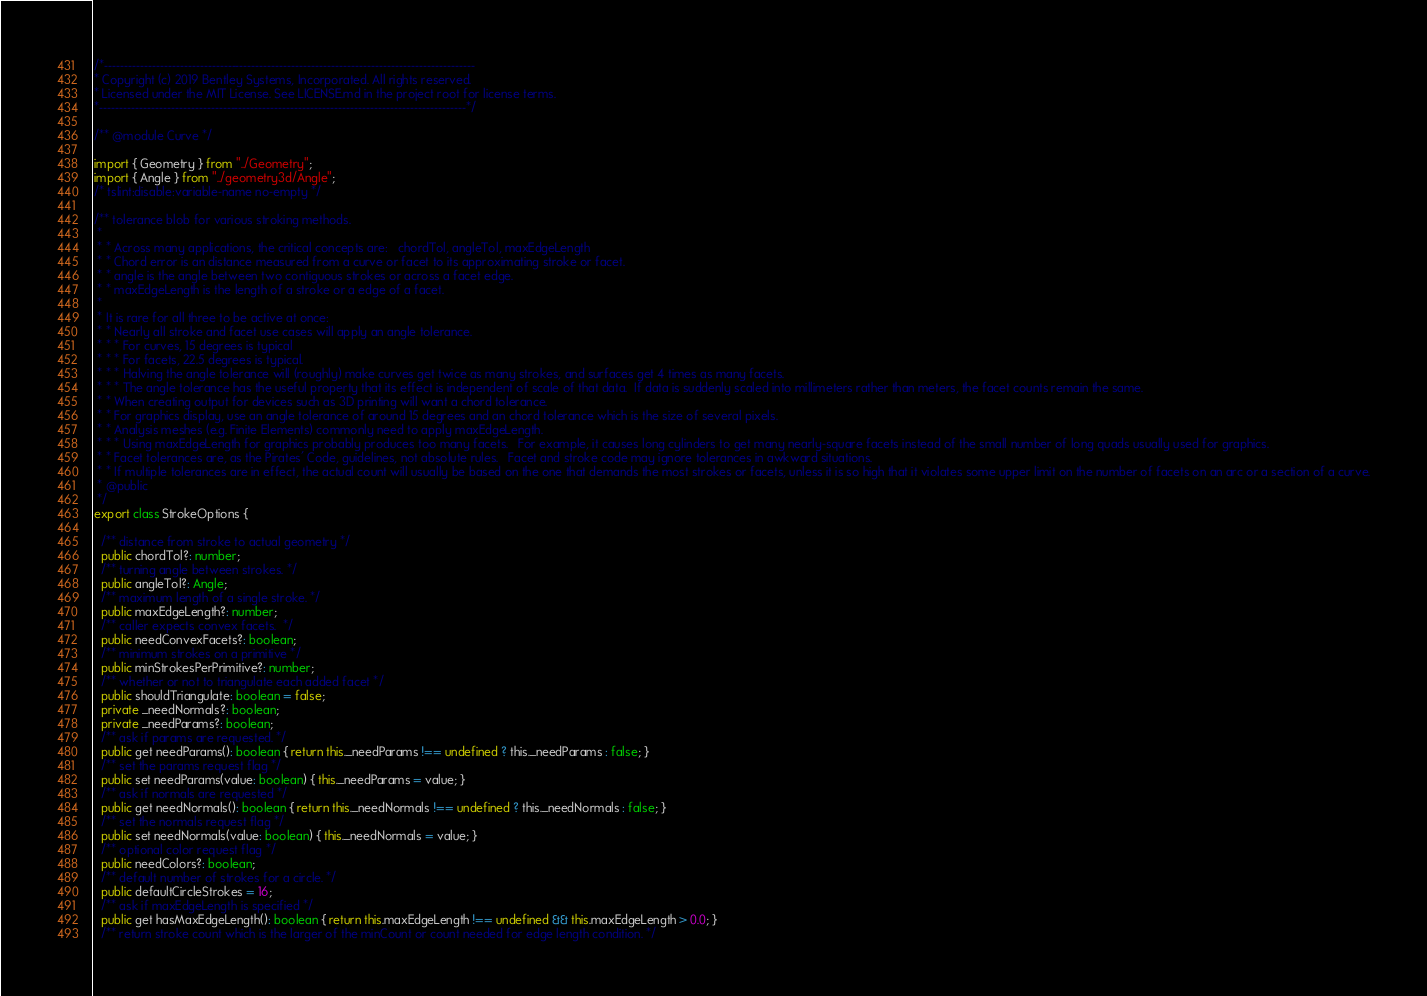<code> <loc_0><loc_0><loc_500><loc_500><_TypeScript_>/*---------------------------------------------------------------------------------------------
* Copyright (c) 2019 Bentley Systems, Incorporated. All rights reserved.
* Licensed under the MIT License. See LICENSE.md in the project root for license terms.
*--------------------------------------------------------------------------------------------*/

/** @module Curve */

import { Geometry } from "../Geometry";
import { Angle } from "../geometry3d/Angle";
/* tslint:disable:variable-name no-empty */

/** tolerance blob for various stroking methods.
 *
 * * Across many applications, the critical concepts are:   chordTol, angleTol, maxEdgeLength
 * * Chord error is an distance measured from a curve or facet to its approximating stroke or facet.
 * * angle is the angle between two contiguous strokes or across a facet edge.
 * * maxEdgeLength is the length of a stroke or a edge of a facet.
 *
 * It is rare for all three to be active at once:
 * * Nearly all stroke and facet use cases will apply an angle tolerance.
 * * * For curves, 15 degrees is typical
 * * * For facets, 22.5 degrees is typical.
 * * * Halving the angle tolerance will (roughly) make curves get twice as many strokes, and surfaces get 4 times as many facets.
 * * * The angle tolerance has the useful property that its effect is independent of scale of that data.  If data is suddenly scaled into millimeters rather than meters, the facet counts remain the same.
 * * When creating output for devices such as 3D printing will want a chord tolerance.
 * * For graphics display, use an angle tolerance of around 15 degrees and an chord tolerance which is the size of several pixels.
 * * Analysis meshes (e.g. Finite Elements) commonly need to apply maxEdgeLength.
 * * * Using maxEdgeLength for graphics probably produces too many facets.   For example, it causes long cylinders to get many nearly-square facets instead of the small number of long quads usually used for graphics.
 * * Facet tolerances are, as the Pirates' Code, guidelines, not absolute rules.   Facet and stroke code may ignore tolerances in awkward situations.
 * * If multiple tolerances are in effect, the actual count will usually be based on the one that demands the most strokes or facets, unless it is so high that it violates some upper limit on the number of facets on an arc or a section of a curve.
 * @public
 */
export class StrokeOptions {

  /** distance from stroke to actual geometry */
  public chordTol?: number;
  /** turning angle between strokes. */
  public angleTol?: Angle;
  /** maximum length of a single stroke. */
  public maxEdgeLength?: number;
  /** caller expects convex facets.  */
  public needConvexFacets?: boolean;
  /** minimum strokes on a primitive */
  public minStrokesPerPrimitive?: number;
  /** whether or not to triangulate each added facet */
  public shouldTriangulate: boolean = false;
  private _needNormals?: boolean;
  private _needParams?: boolean;
  /** ask if params are requested. */
  public get needParams(): boolean { return this._needParams !== undefined ? this._needParams : false; }
  /** set the params request flag */
  public set needParams(value: boolean) { this._needParams = value; }
  /** ask if normals are requested */
  public get needNormals(): boolean { return this._needNormals !== undefined ? this._needNormals : false; }
  /** set the normals request flag */
  public set needNormals(value: boolean) { this._needNormals = value; }
  /** optional color request flag */
  public needColors?: boolean;
  /** default number of strokes for a circle. */
  public defaultCircleStrokes = 16;
  /** ask if maxEdgeLength is specified */
  public get hasMaxEdgeLength(): boolean { return this.maxEdgeLength !== undefined && this.maxEdgeLength > 0.0; }
  /** return stroke count which is the larger of the minCount or count needed for edge length condition. */</code> 